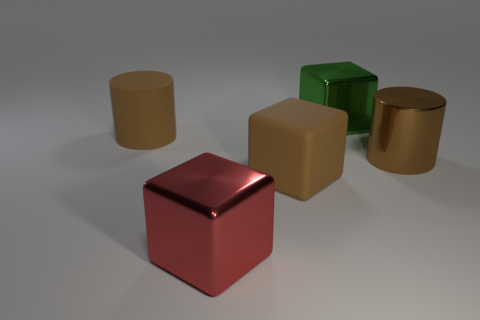Are the big red cube and the large brown cylinder right of the large green block made of the same material?
Your answer should be very brief. Yes. There is a cube that is the same color as the matte cylinder; what material is it?
Your answer should be very brief. Rubber. How many metal blocks have the same color as the shiny cylinder?
Your answer should be compact. 0. What size is the brown cube?
Make the answer very short. Large. There is a large green metallic thing; is its shape the same as the brown rubber object that is on the right side of the large red cube?
Give a very brief answer. Yes. The thing that is made of the same material as the brown block is what color?
Your answer should be very brief. Brown. There is a brown matte thing in front of the large brown matte cylinder; what is its size?
Keep it short and to the point. Large. Are there fewer big brown cylinders in front of the large red block than large metal cubes?
Your answer should be very brief. Yes. Do the large metallic cylinder and the rubber cylinder have the same color?
Offer a terse response. Yes. Are there any other things that are the same shape as the green object?
Keep it short and to the point. Yes. 